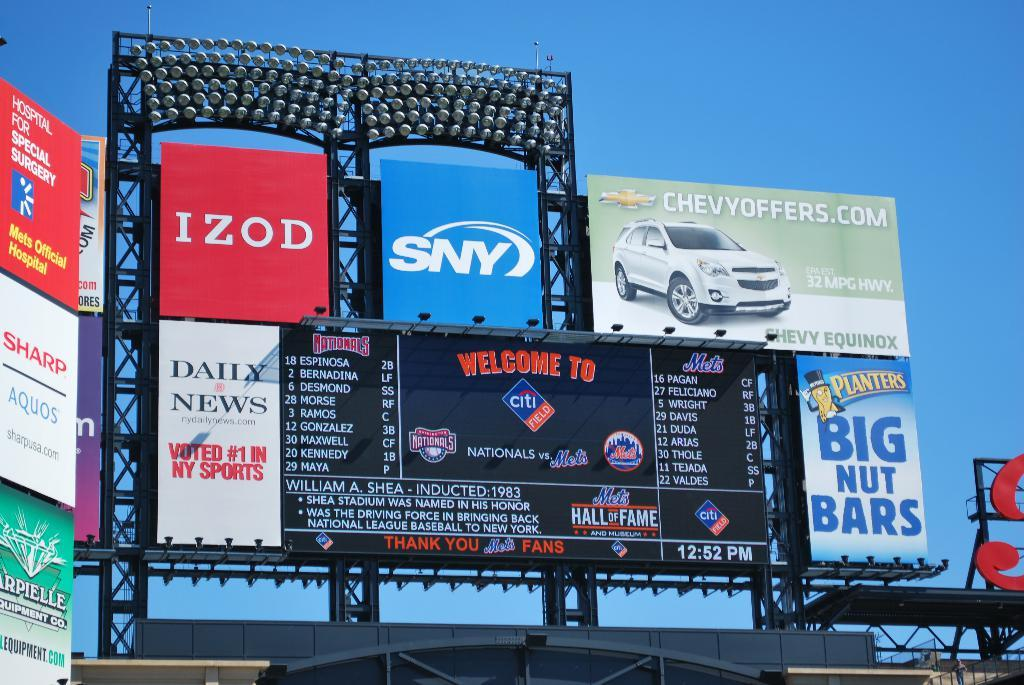Provide a one-sentence caption for the provided image. Huge advertising board with Izod, Chevy, SNY and daily news. 